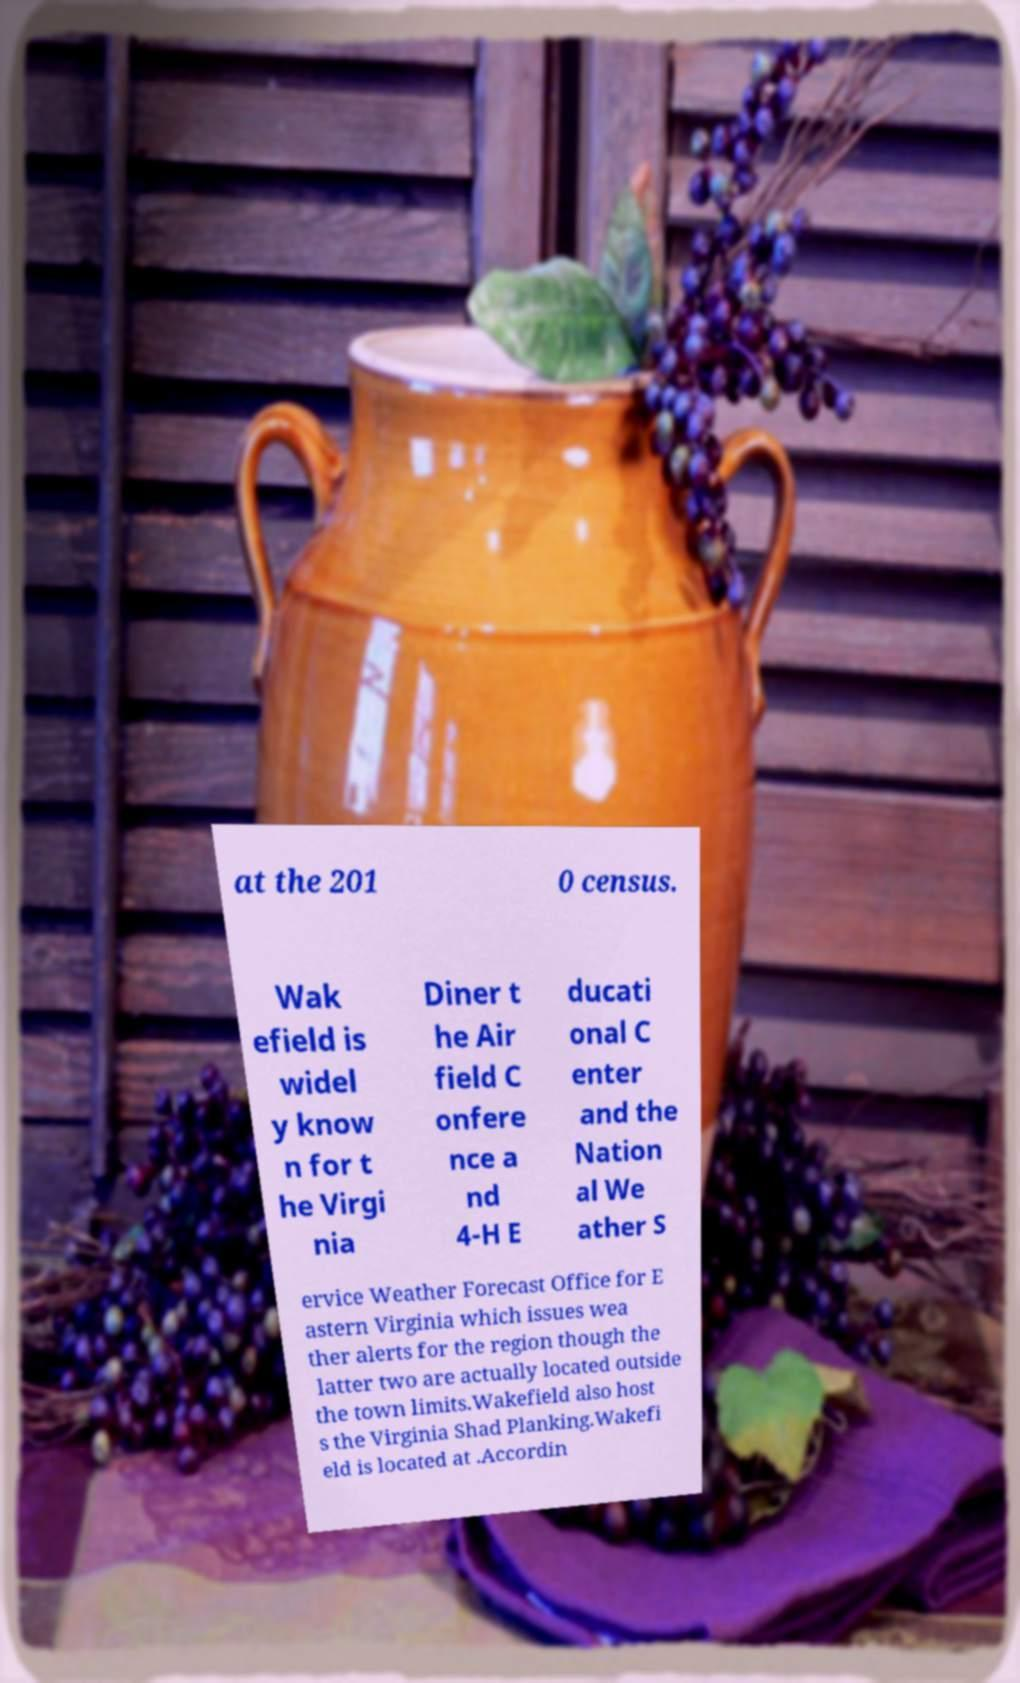Please identify and transcribe the text found in this image. at the 201 0 census. Wak efield is widel y know n for t he Virgi nia Diner t he Air field C onfere nce a nd 4-H E ducati onal C enter and the Nation al We ather S ervice Weather Forecast Office for E astern Virginia which issues wea ther alerts for the region though the latter two are actually located outside the town limits.Wakefield also host s the Virginia Shad Planking.Wakefi eld is located at .Accordin 